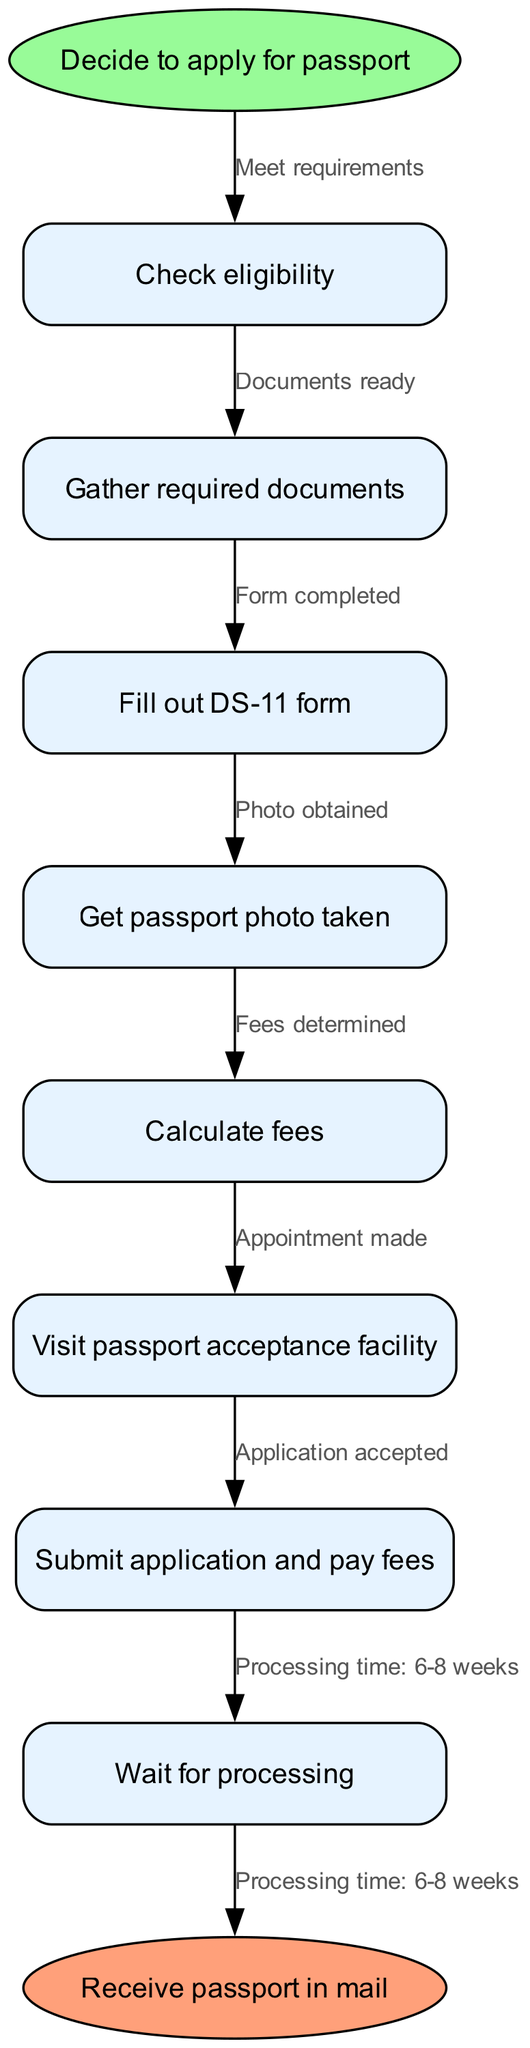What is the first step in applying for a passport? The first step in the flow chart indicates starting with the decision to apply for a passport, which is labeled as "Decide to apply for passport."
Answer: Decide to apply for passport How many nodes are in the diagram, excluding start and end nodes? The diagram has 7 process nodes listed: "Check eligibility," "Gather required documents," "Fill out DS-11 form," "Get passport photo taken," "Calculate fees," "Visit passport acceptance facility," and "Submit application and pay fees." Excluding the start and end nodes, there are 7 nodes.
Answer: 7 What is the last action before receiving the passport? The last action before receiving the passport is "Wait for processing," which leads to the end node of receiving the passport in the mail.
Answer: Wait for processing What document needs to be filled out during the passport application process? According to the diagram, the document that needs to be filled out is the "DS-11 form."
Answer: DS-11 form What is the expected processing time after submitting the application? The processing time indicated in the diagram after submitting the application and paying fees is "6-8 weeks."
Answer: 6-8 weeks Which step follows "Get passport photo taken"? The step that directly follows "Get passport photo taken" is "Calculate fees," according to the sequential flow of the diagram.
Answer: Calculate fees How do you determine if you're eligible to apply for a passport? You check eligibility at the very beginning, which is the first node after the start node. Meeting the requirements is the relationship established by the edge from "Decide to apply for passport" to "Check eligibility."
Answer: Meet requirements What action is taken before you visit the passport acceptance facility? Before visiting the passport acceptance facility, you must "Calculate fees," which is a necessary step that precedes the facility visit.
Answer: Calculate fees What is the last node labeled in the diagram? The last node in the diagram is labeled "Receive passport in mail," which represents the final outcome of the application process.
Answer: Receive passport in mail 